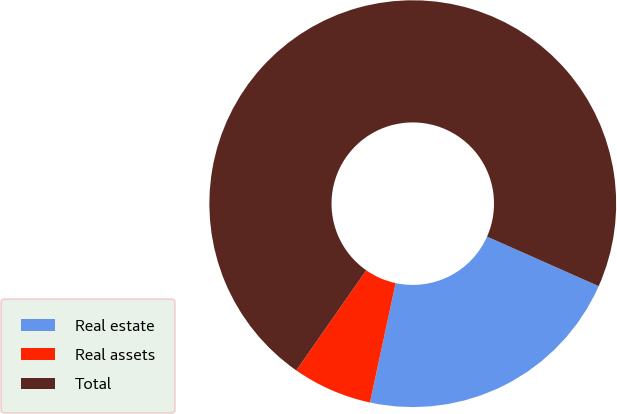Convert chart to OTSL. <chart><loc_0><loc_0><loc_500><loc_500><pie_chart><fcel>Real estate<fcel>Real assets<fcel>Total<nl><fcel>21.73%<fcel>6.33%<fcel>71.94%<nl></chart> 